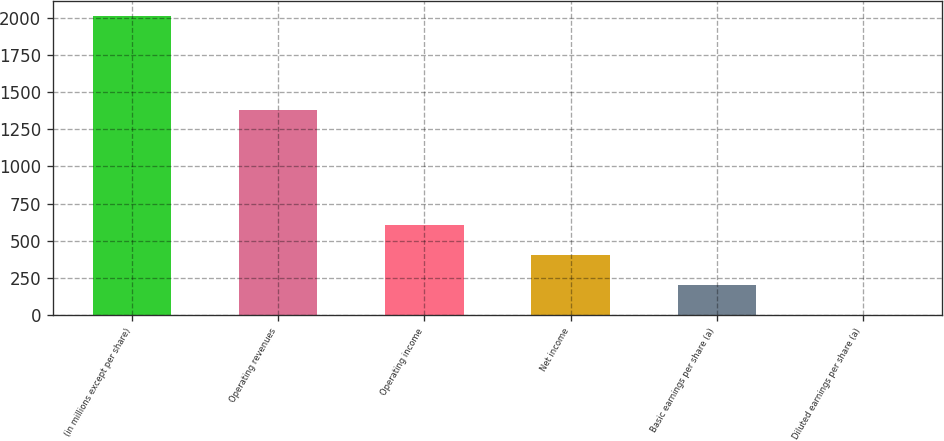Convert chart. <chart><loc_0><loc_0><loc_500><loc_500><bar_chart><fcel>(in millions except per share)<fcel>Operating revenues<fcel>Operating income<fcel>Net income<fcel>Basic earnings per share (a)<fcel>Diluted earnings per share (a)<nl><fcel>2015<fcel>1377<fcel>605.56<fcel>404.21<fcel>202.86<fcel>1.51<nl></chart> 